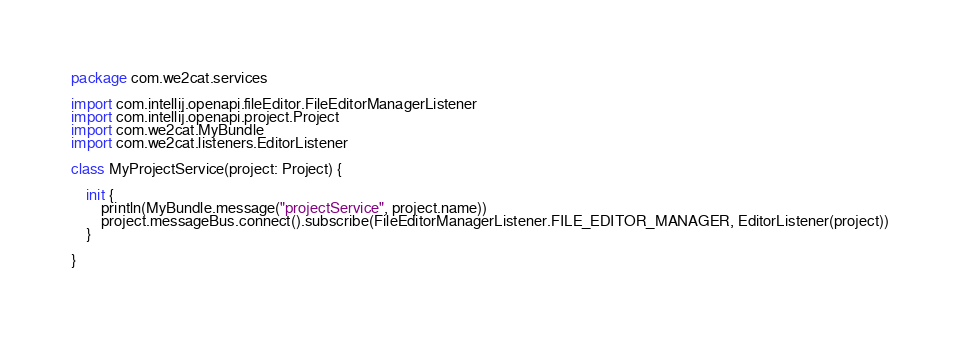<code> <loc_0><loc_0><loc_500><loc_500><_Kotlin_>package com.we2cat.services

import com.intellij.openapi.fileEditor.FileEditorManagerListener
import com.intellij.openapi.project.Project
import com.we2cat.MyBundle
import com.we2cat.listeners.EditorListener

class MyProjectService(project: Project) {

    init {
        println(MyBundle.message("projectService", project.name))
        project.messageBus.connect().subscribe(FileEditorManagerListener.FILE_EDITOR_MANAGER, EditorListener(project))
    }

}
</code> 